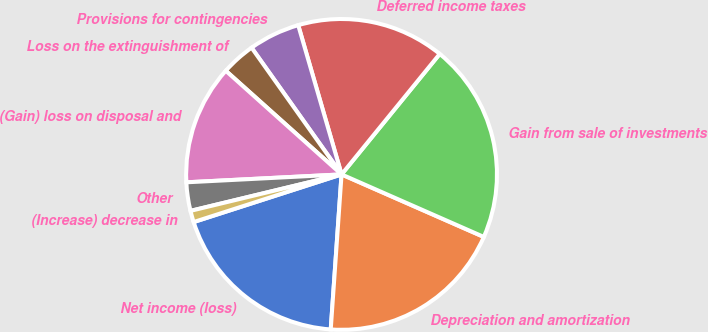<chart> <loc_0><loc_0><loc_500><loc_500><pie_chart><fcel>Net income (loss)<fcel>Depreciation and amortization<fcel>Gain from sale of investments<fcel>Deferred income taxes<fcel>Provisions for contingencies<fcel>Loss on the extinguishment of<fcel>(Gain) loss on disposal and<fcel>Other<fcel>(Increase) decrease in<nl><fcel>18.93%<fcel>19.52%<fcel>20.71%<fcel>15.38%<fcel>5.33%<fcel>3.55%<fcel>12.43%<fcel>2.96%<fcel>1.19%<nl></chart> 